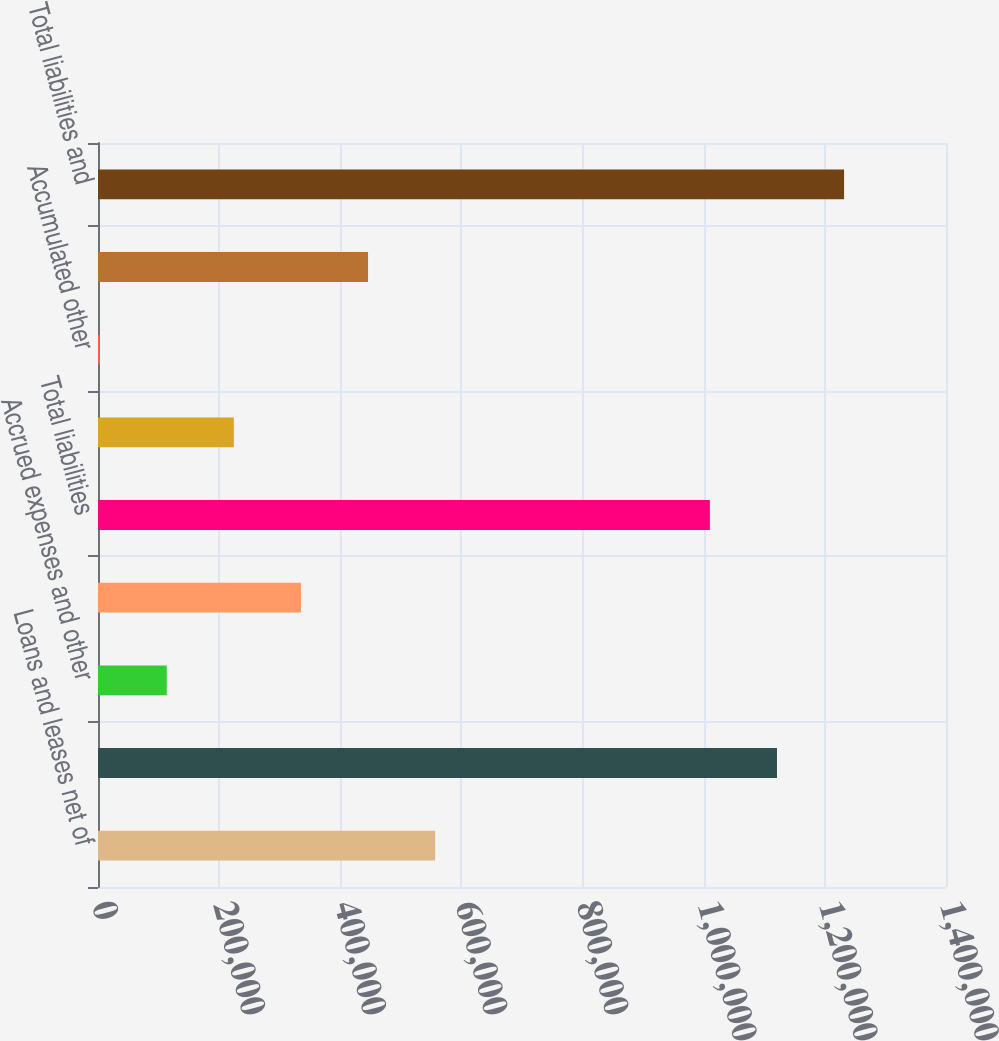Convert chart. <chart><loc_0><loc_0><loc_500><loc_500><bar_chart><fcel>Loans and leases net of<fcel>Total assets<fcel>Accrued expenses and other<fcel>Long-term debt<fcel>Total liabilities<fcel>Retainedearnings<fcel>Accumulated other<fcel>Total shareholders' equity<fcel>Total liabilities and<nl><fcel>556598<fcel>1.12096e+06<fcel>113531<fcel>335064<fcel>1.0102e+06<fcel>224298<fcel>2764<fcel>445831<fcel>1.23173e+06<nl></chart> 